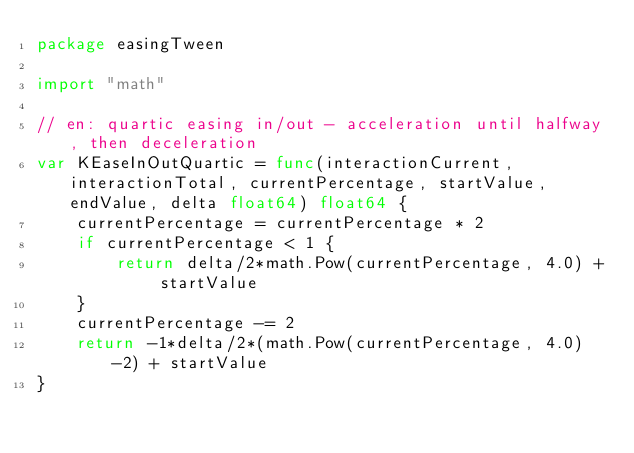Convert code to text. <code><loc_0><loc_0><loc_500><loc_500><_Go_>package easingTween

import "math"

// en: quartic easing in/out - acceleration until halfway, then deceleration
var KEaseInOutQuartic = func(interactionCurrent, interactionTotal, currentPercentage, startValue, endValue, delta float64) float64 {
	currentPercentage = currentPercentage * 2
	if currentPercentage < 1 {
		return delta/2*math.Pow(currentPercentage, 4.0) + startValue
	}
	currentPercentage -= 2
	return -1*delta/2*(math.Pow(currentPercentage, 4.0)-2) + startValue
}
</code> 